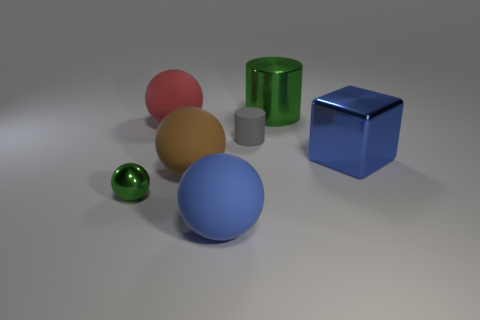Can you tell me the colors of the objects in the image? Certainly! There are six objects and they display a range of colors: red, green, blue, brown, beige, and a smaller one that appears to be shiny metallic green. 